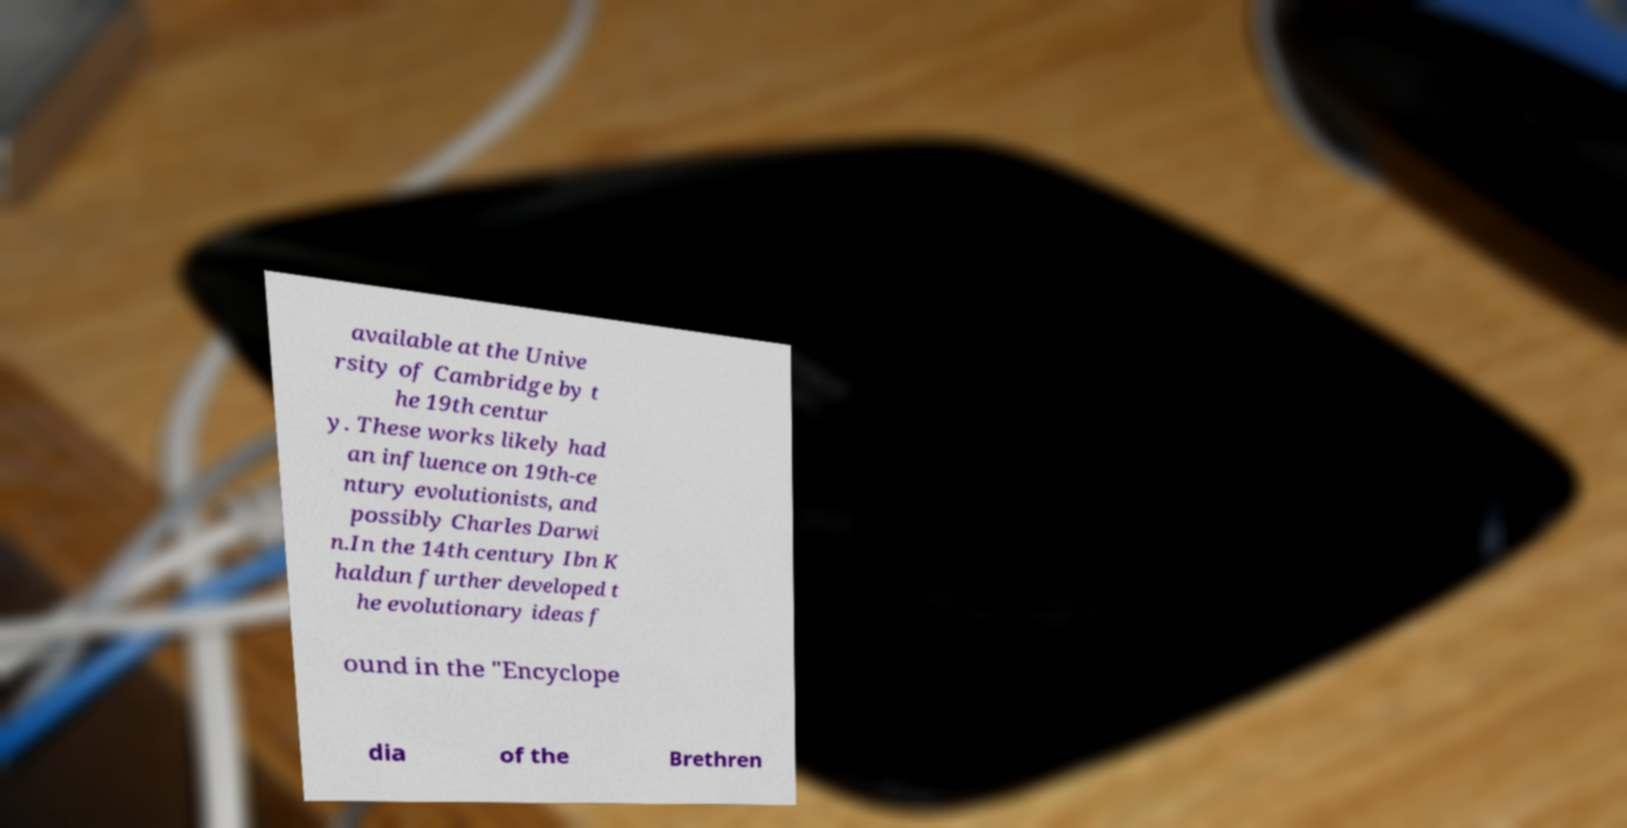Could you extract and type out the text from this image? available at the Unive rsity of Cambridge by t he 19th centur y. These works likely had an influence on 19th-ce ntury evolutionists, and possibly Charles Darwi n.In the 14th century Ibn K haldun further developed t he evolutionary ideas f ound in the "Encyclope dia of the Brethren 